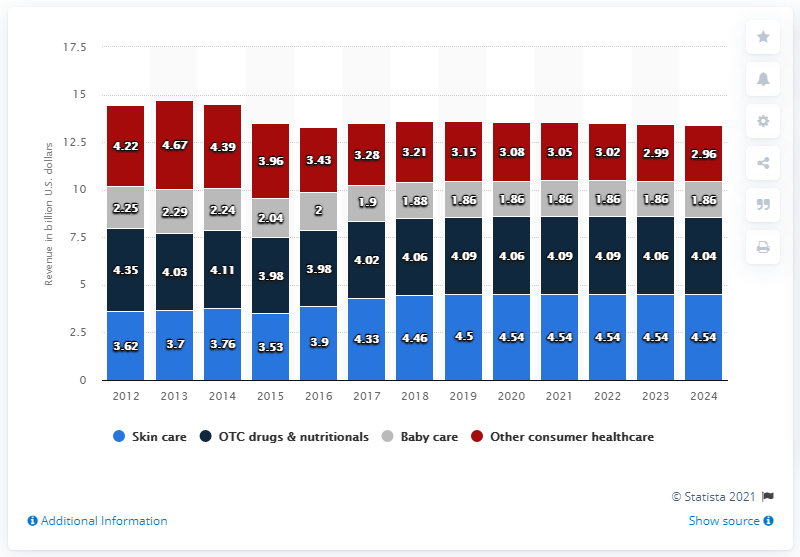Indicate a few pertinent items in this graphic. Johnson & Johnson's skin care segment generated approximately 4.5 billion in revenue in 2018. 